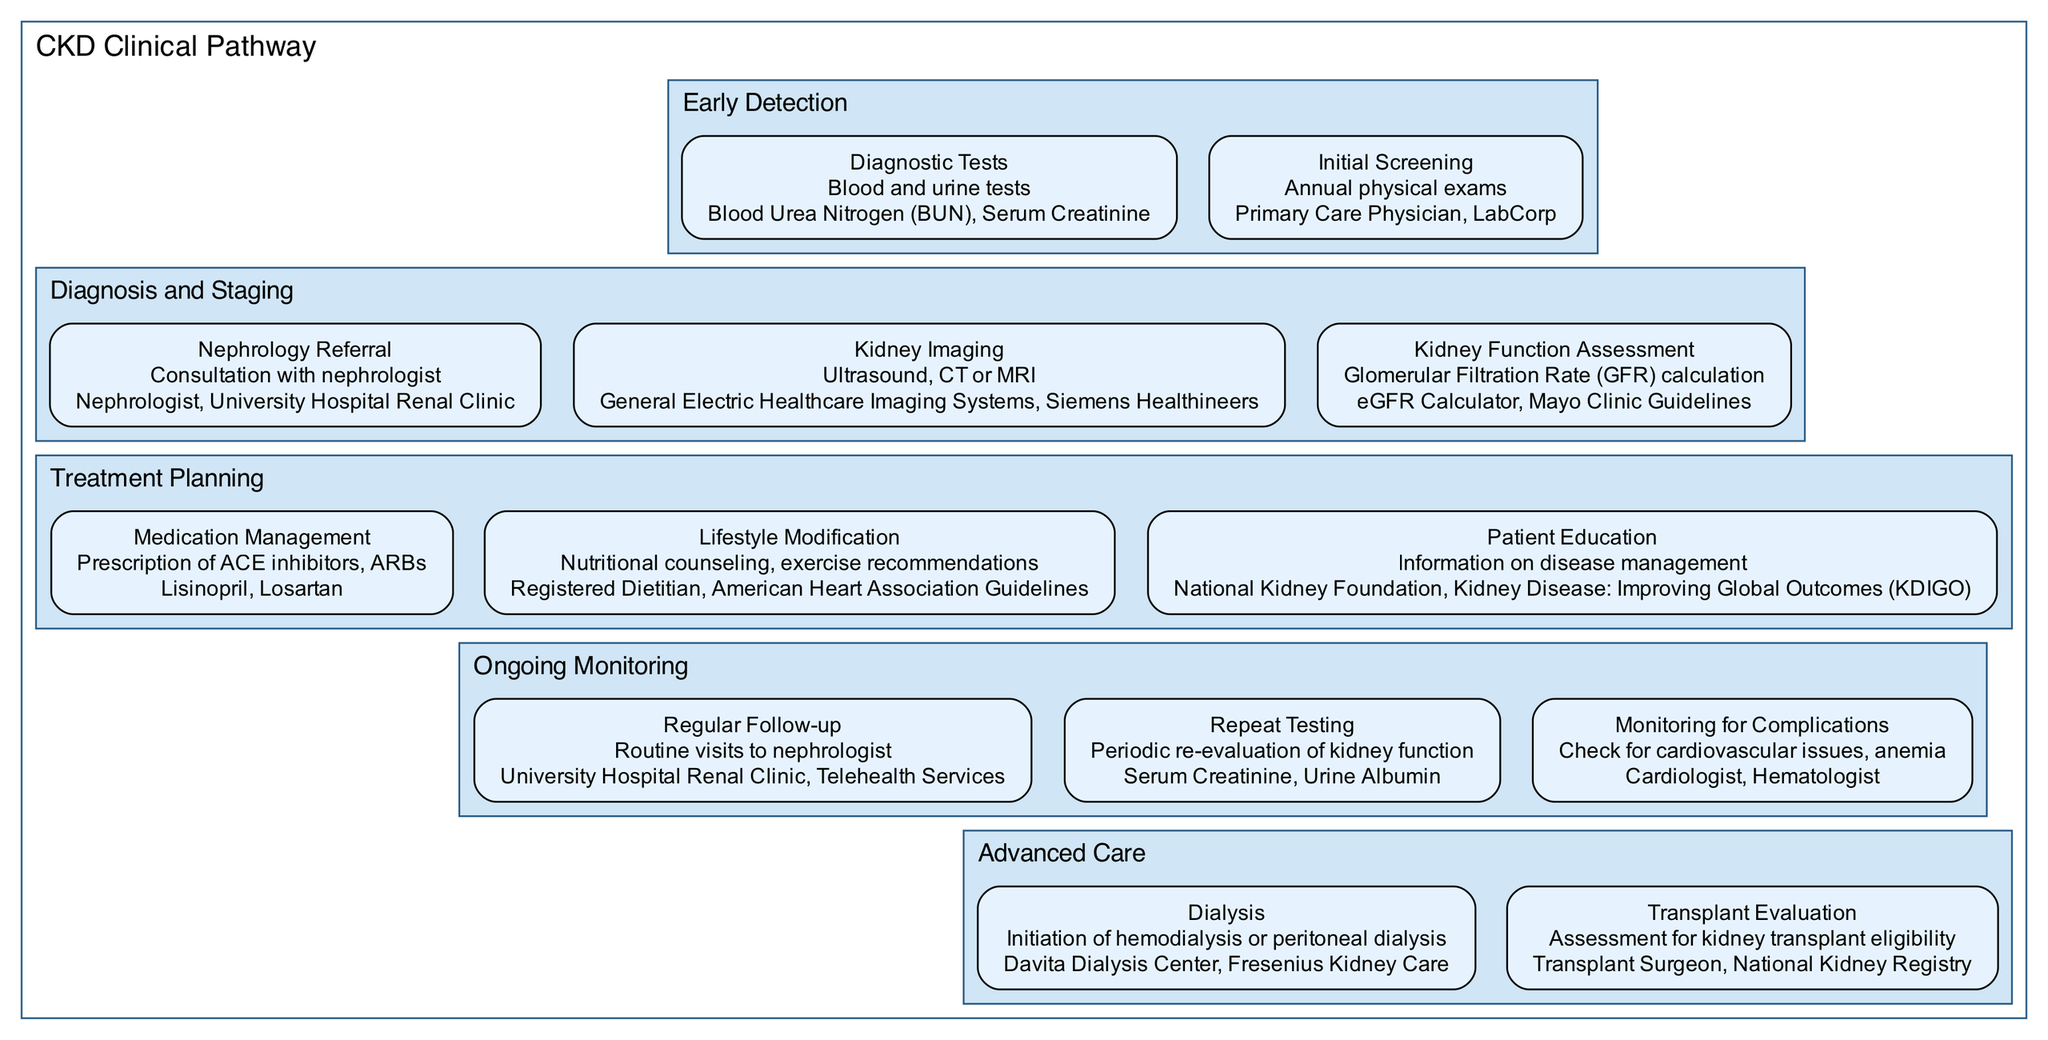What is the first stage in the CKD Clinical Pathway? The diagram starts with the "Early Detection" stage, which is the first stage listed.
Answer: Early Detection How many steps are in the Diagnosis and Staging stage? In the Diagnosis and Staging stage, there are three steps: Nephrology Referral, Kidney Imaging, and Kidney Function Assessment.
Answer: 3 What type of tests are performed during Initial Screening? The Initial Screening step mentions "Annual physical exams" and relates to the involvement of primary care physicians and diagnostic labs.
Answer: Annual physical exams Which entity is associated with the Medication Management step? The Medication Management step lists specific medications like Lisinopril and Losartan, pointing out that the nephrologist prescribes them.
Answer: Nephrologist What is the last step in the Advanced Care stage? The Advanced Care stage concludes with the "Transplant Evaluation" step, which is focused on assessing transplant eligibility.
Answer: Transplant Evaluation What is the relationship between Regular Follow-up and Repeat Testing? Regular Follow-up is part of ongoing monitoring, and both steps are essential for tracking the patient’s kidney function.
Answer: Both are part of Ongoing Monitoring How many total stages are in the CKD Clinical Pathway? The diagram includes five stages: Early Detection, Diagnosis and Staging, Treatment Planning, Ongoing Monitoring, and Advanced Care.
Answer: 5 What is the purpose of Lifestyle Modification in the Treatment Planning stage? Lifestyle Modification aims to provide nutritional counseling and exercise recommendations to improve patient health and management of CKD.
Answer: Nutritional counseling, exercise recommendations Which two entities are listed for Kidney Imaging? The Kidney Imaging step mentions "General Electric Healthcare Imaging Systems" and "Siemens Healthineers" as entities involved in imaging procedures.
Answer: General Electric Healthcare Imaging Systems, Siemens Healthineers 